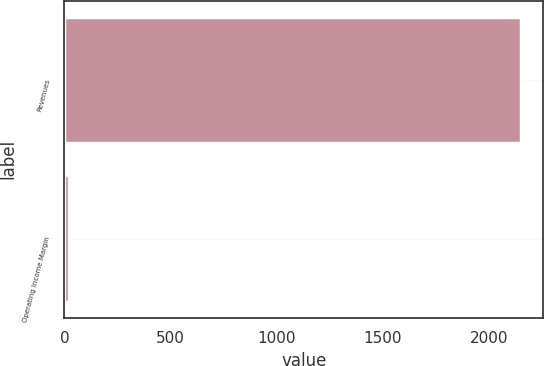<chart> <loc_0><loc_0><loc_500><loc_500><bar_chart><fcel>Revenues<fcel>Operating Income Margin<nl><fcel>2149<fcel>22.7<nl></chart> 